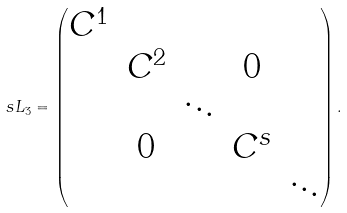Convert formula to latex. <formula><loc_0><loc_0><loc_500><loc_500>\ s L _ { 3 } = \begin{pmatrix} C ^ { 1 } & & & & \\ & C ^ { 2 } & & 0 & \\ & & \ddots & & \\ & 0 & & C ^ { s } & \\ & & & & \ddots \end{pmatrix} .</formula> 